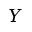<formula> <loc_0><loc_0><loc_500><loc_500>Y</formula> 